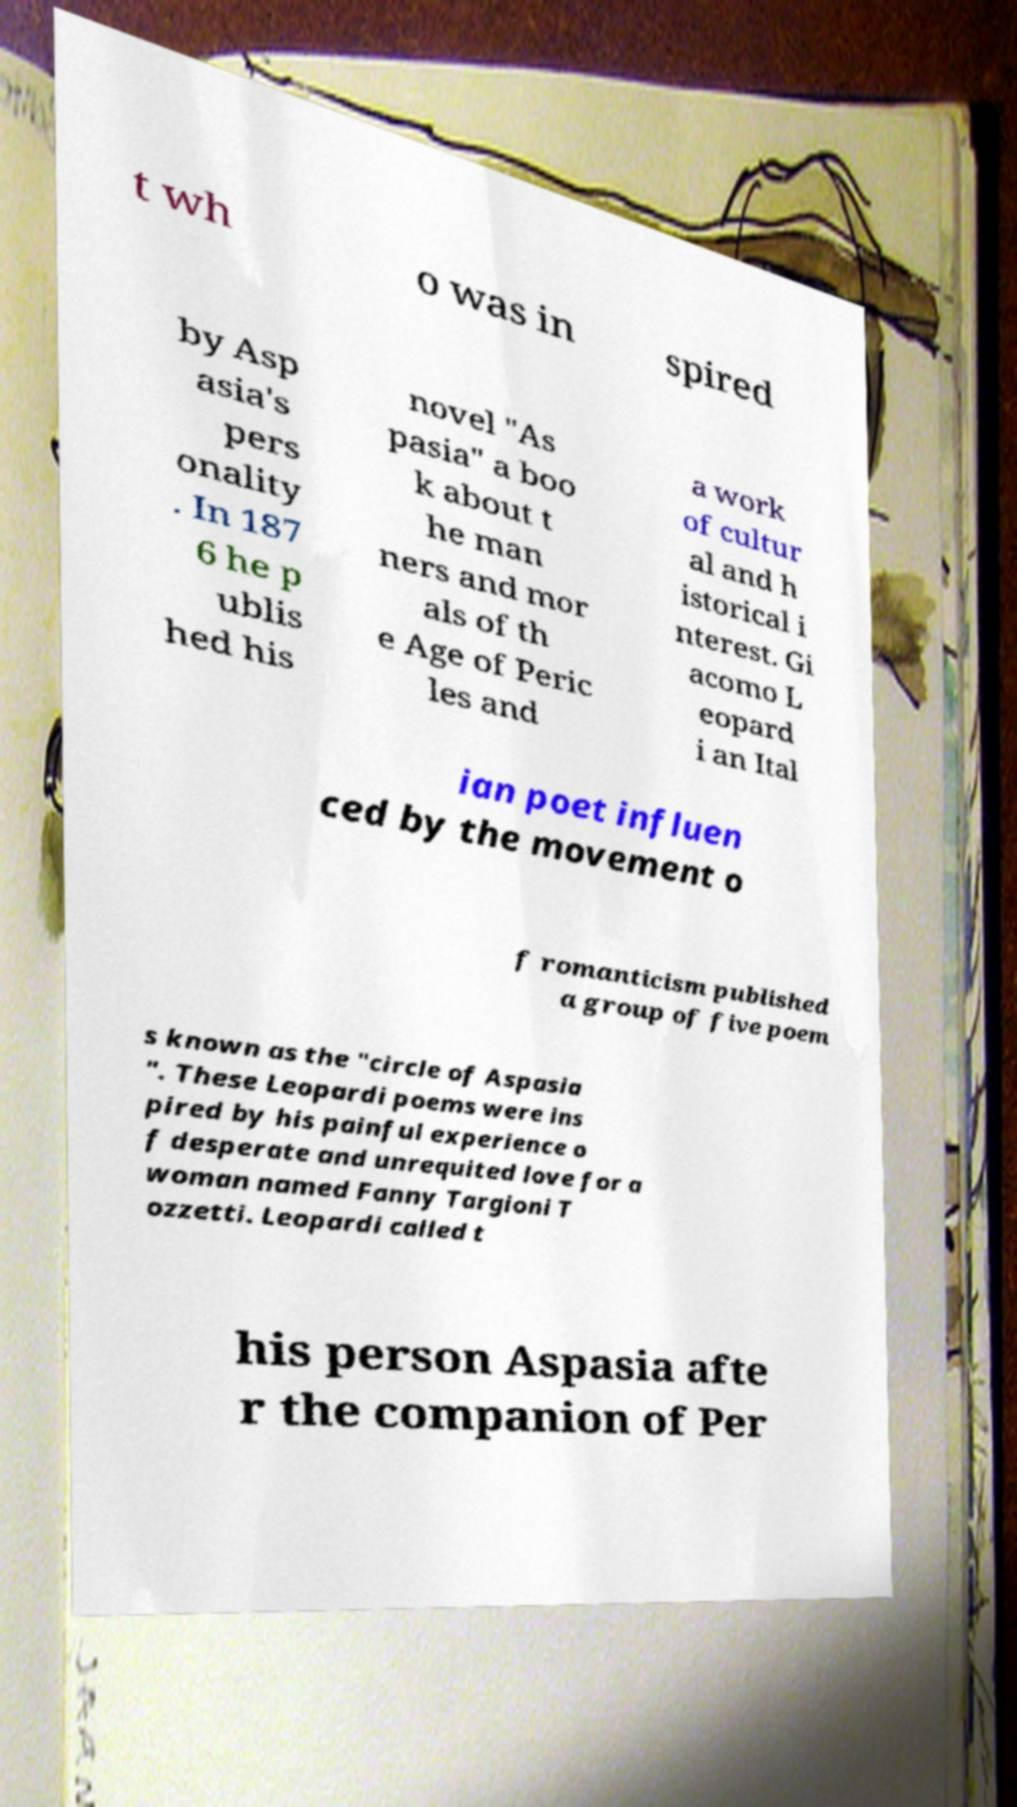Please identify and transcribe the text found in this image. t wh o was in spired by Asp asia's pers onality . In 187 6 he p ublis hed his novel "As pasia" a boo k about t he man ners and mor als of th e Age of Peric les and a work of cultur al and h istorical i nterest. Gi acomo L eopard i an Ital ian poet influen ced by the movement o f romanticism published a group of five poem s known as the "circle of Aspasia ". These Leopardi poems were ins pired by his painful experience o f desperate and unrequited love for a woman named Fanny Targioni T ozzetti. Leopardi called t his person Aspasia afte r the companion of Per 